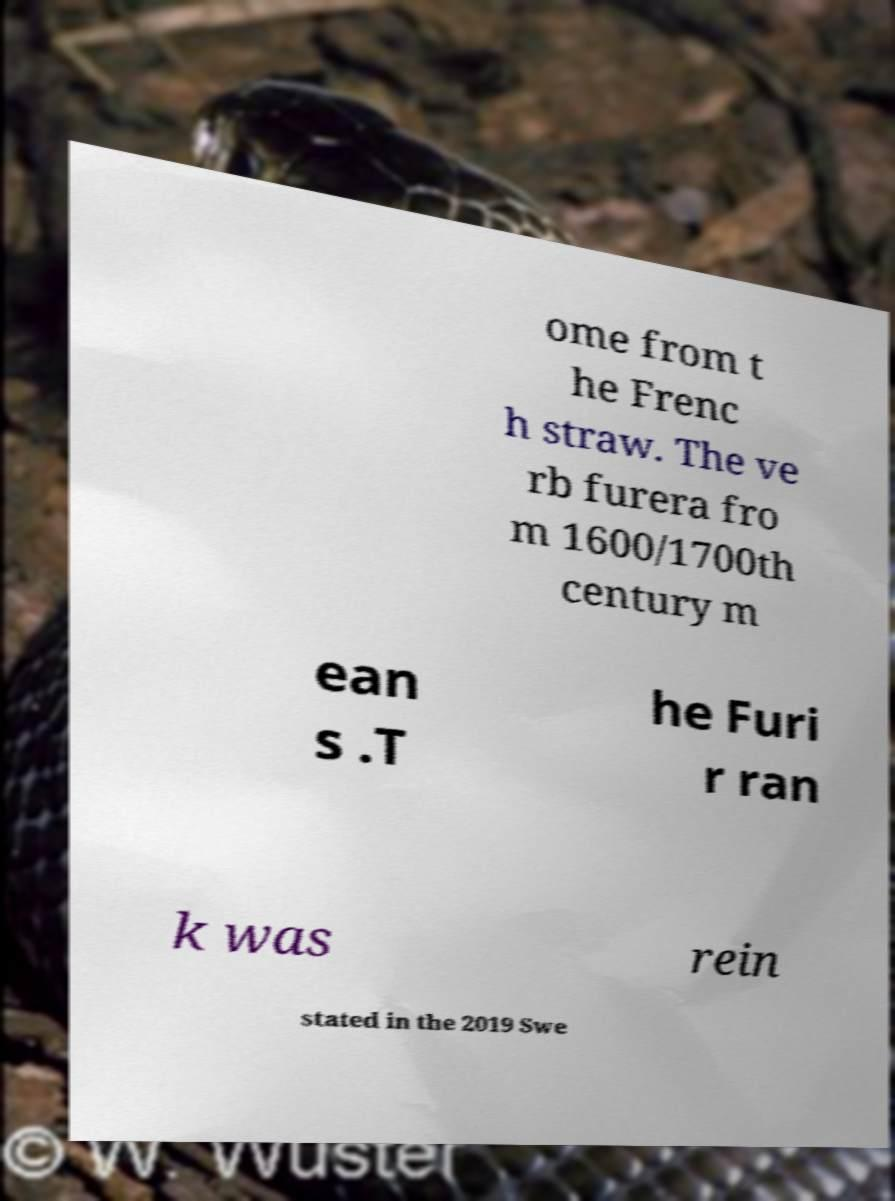Please read and relay the text visible in this image. What does it say? ome from t he Frenc h straw. The ve rb furera fro m 1600/1700th century m ean s .T he Furi r ran k was rein stated in the 2019 Swe 